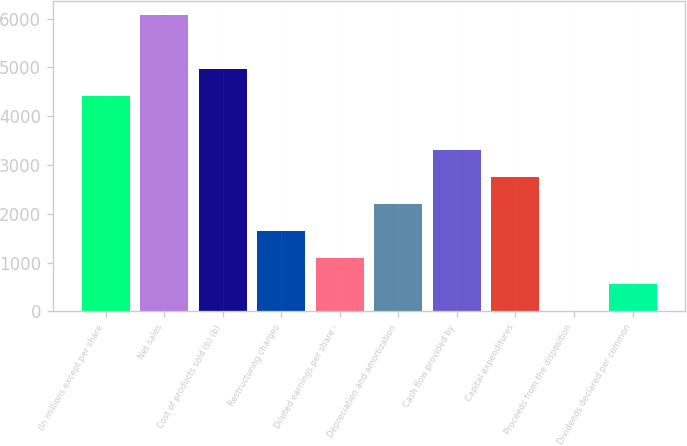Convert chart. <chart><loc_0><loc_0><loc_500><loc_500><bar_chart><fcel>(In millions except per share<fcel>Net sales<fcel>Cost of products sold (b) (b)<fcel>Restructuring charges<fcel>Diluted earnings per share -<fcel>Depreciation and amortization<fcel>Cash flow provided by<fcel>Capital expenditures<fcel>Proceeds from the disposition<fcel>Dividends declared per common<nl><fcel>4409.2<fcel>6062.5<fcel>4960.3<fcel>1653.7<fcel>1102.6<fcel>2204.8<fcel>3307<fcel>2755.9<fcel>0.4<fcel>551.5<nl></chart> 